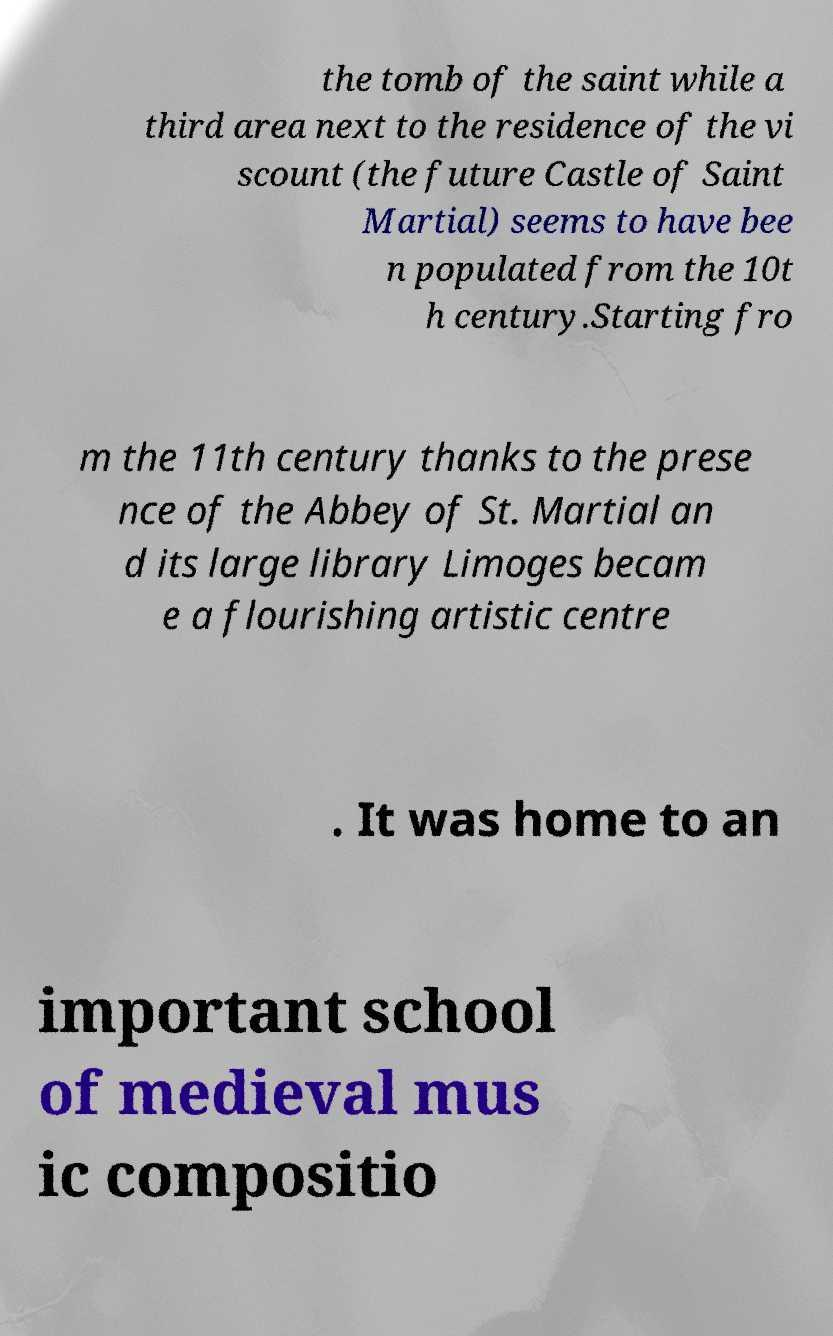Can you read and provide the text displayed in the image?This photo seems to have some interesting text. Can you extract and type it out for me? the tomb of the saint while a third area next to the residence of the vi scount (the future Castle of Saint Martial) seems to have bee n populated from the 10t h century.Starting fro m the 11th century thanks to the prese nce of the Abbey of St. Martial an d its large library Limoges becam e a flourishing artistic centre . It was home to an important school of medieval mus ic compositio 